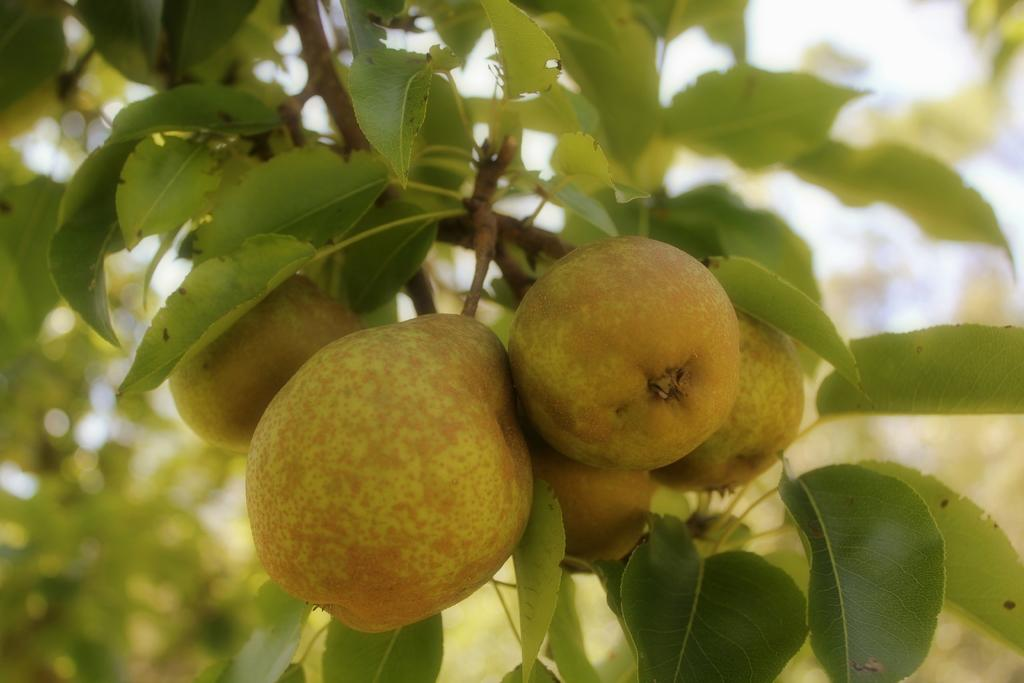What type of tree branch is visible in the image? There is a branch of a pear tree in the image. Are there any fruits on the branch? Yes, there are fruits on the branch. What type of seashore can be seen in the background of the image? There is no seashore visible in the image; it features a branch of a pear tree with fruits. 